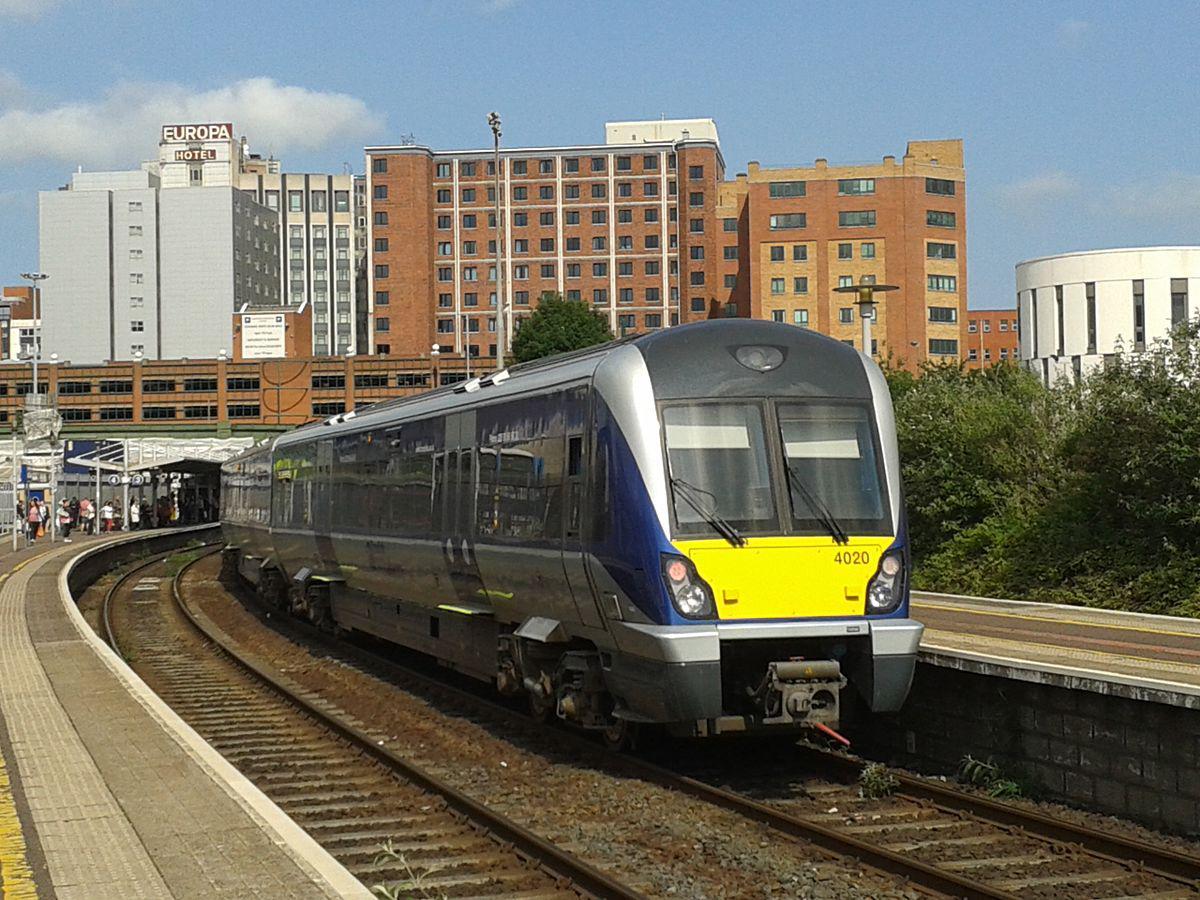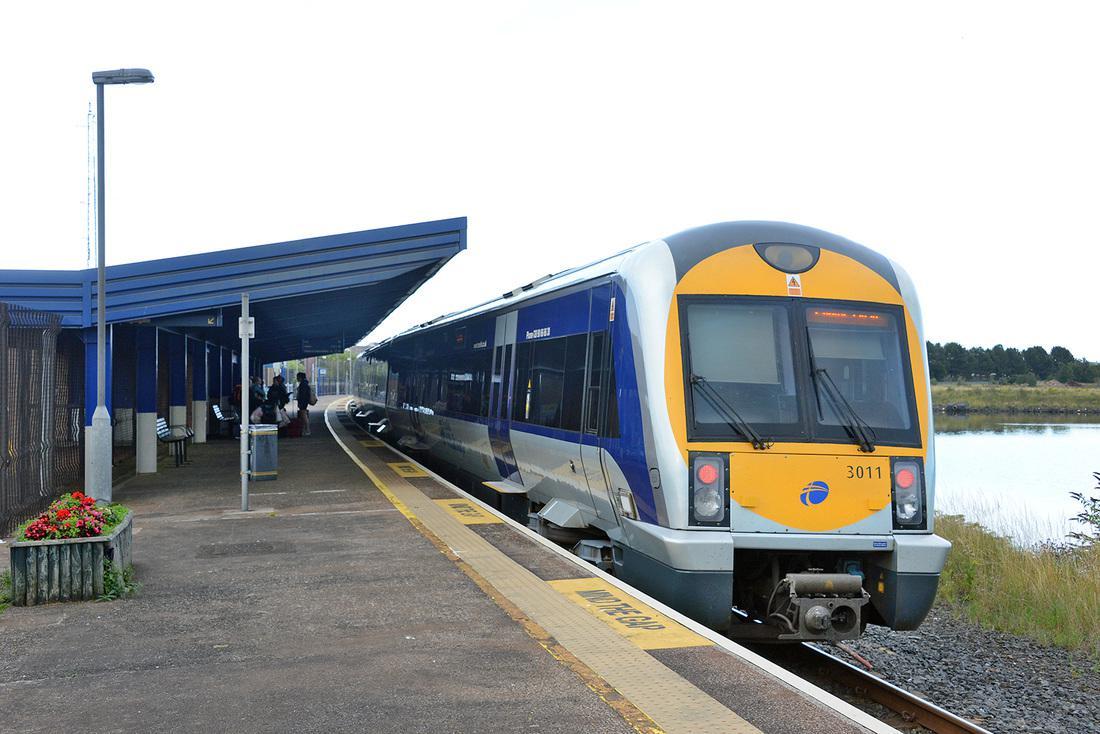The first image is the image on the left, the second image is the image on the right. Analyze the images presented: Is the assertion "There are two trains in total traveling in the same direction." valid? Answer yes or no. Yes. The first image is the image on the left, the second image is the image on the right. For the images shown, is this caption "In total, the images contain two trains featuring blue and yellow coloring." true? Answer yes or no. Yes. 